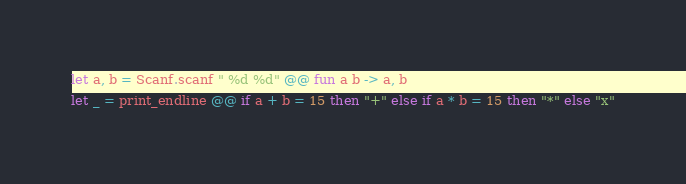Convert code to text. <code><loc_0><loc_0><loc_500><loc_500><_OCaml_>let a, b = Scanf.scanf " %d %d" @@ fun a b -> a, b
let _ = print_endline @@ if a + b = 15 then "+" else if a * b = 15 then "*" else "x"</code> 